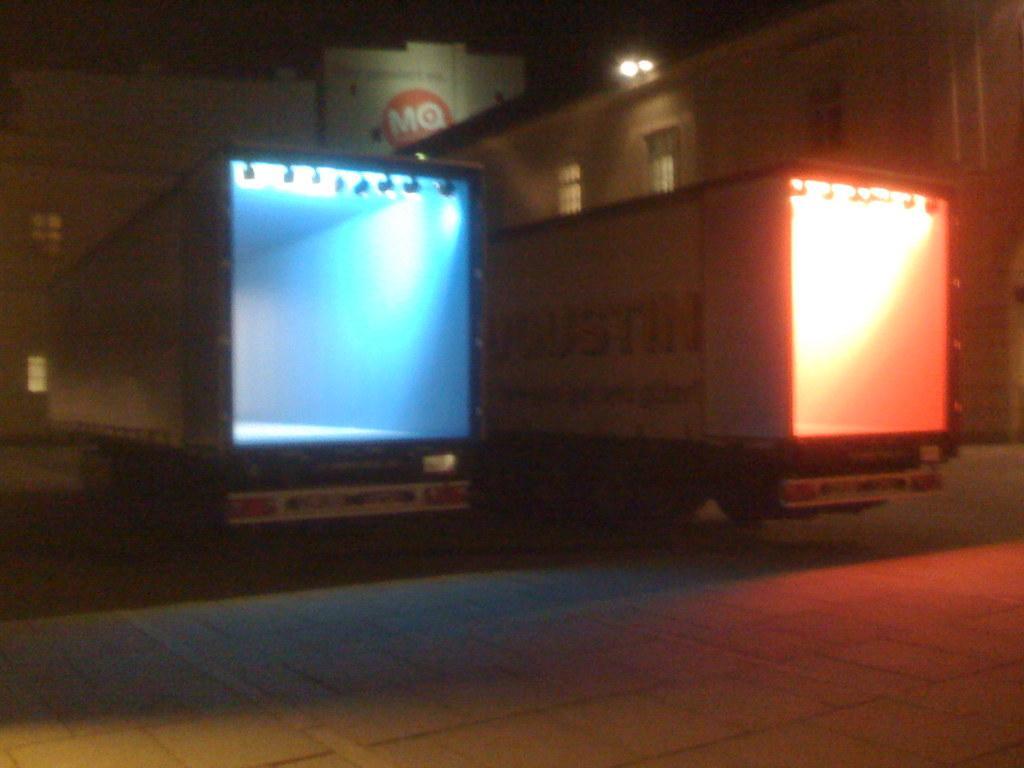Describe this image in one or two sentences. In this image in the center there are two vehicles, and in the background there are buildings and lights, at the bottom there is a walkway. 